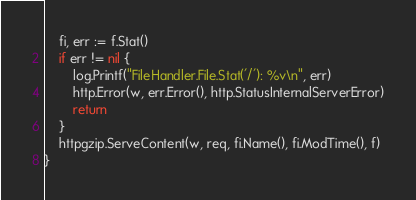Convert code to text. <code><loc_0><loc_0><loc_500><loc_500><_Go_>	fi, err := f.Stat()
	if err != nil {
		log.Printf("FileHandler.File.Stat('/'): %v\n", err)
		http.Error(w, err.Error(), http.StatusInternalServerError)
		return
	}
	httpgzip.ServeContent(w, req, fi.Name(), fi.ModTime(), f)
}
</code> 